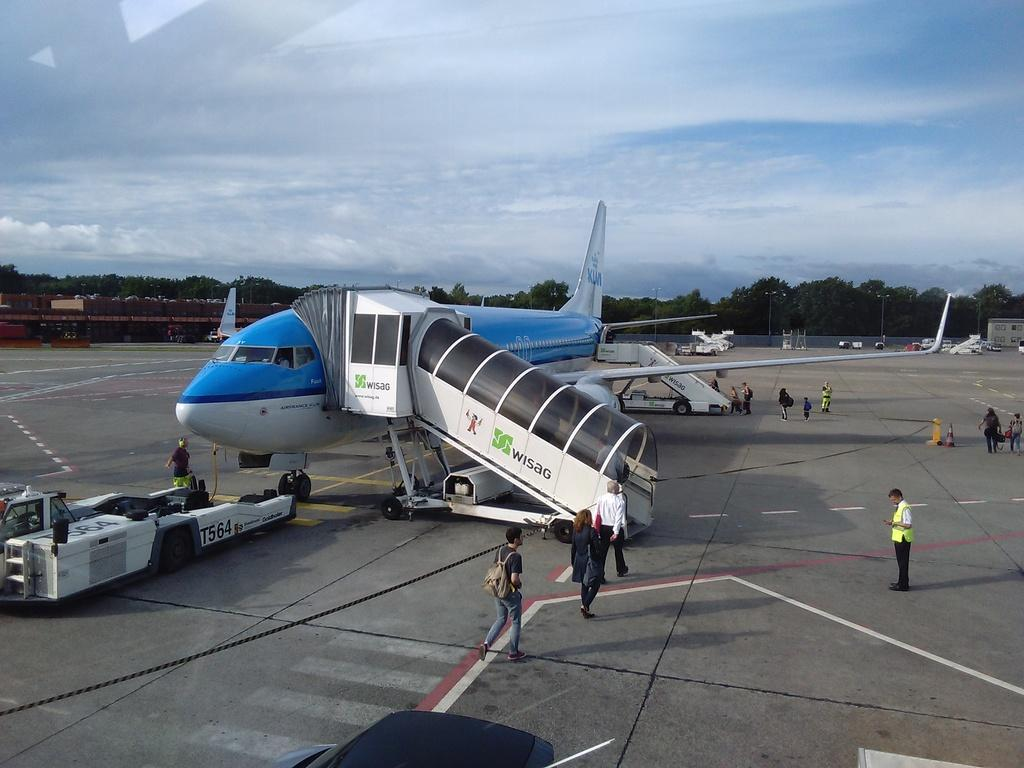<image>
Provide a brief description of the given image. Several people are in the process of boarding an AIR FRANCE plane on a tarmac. 